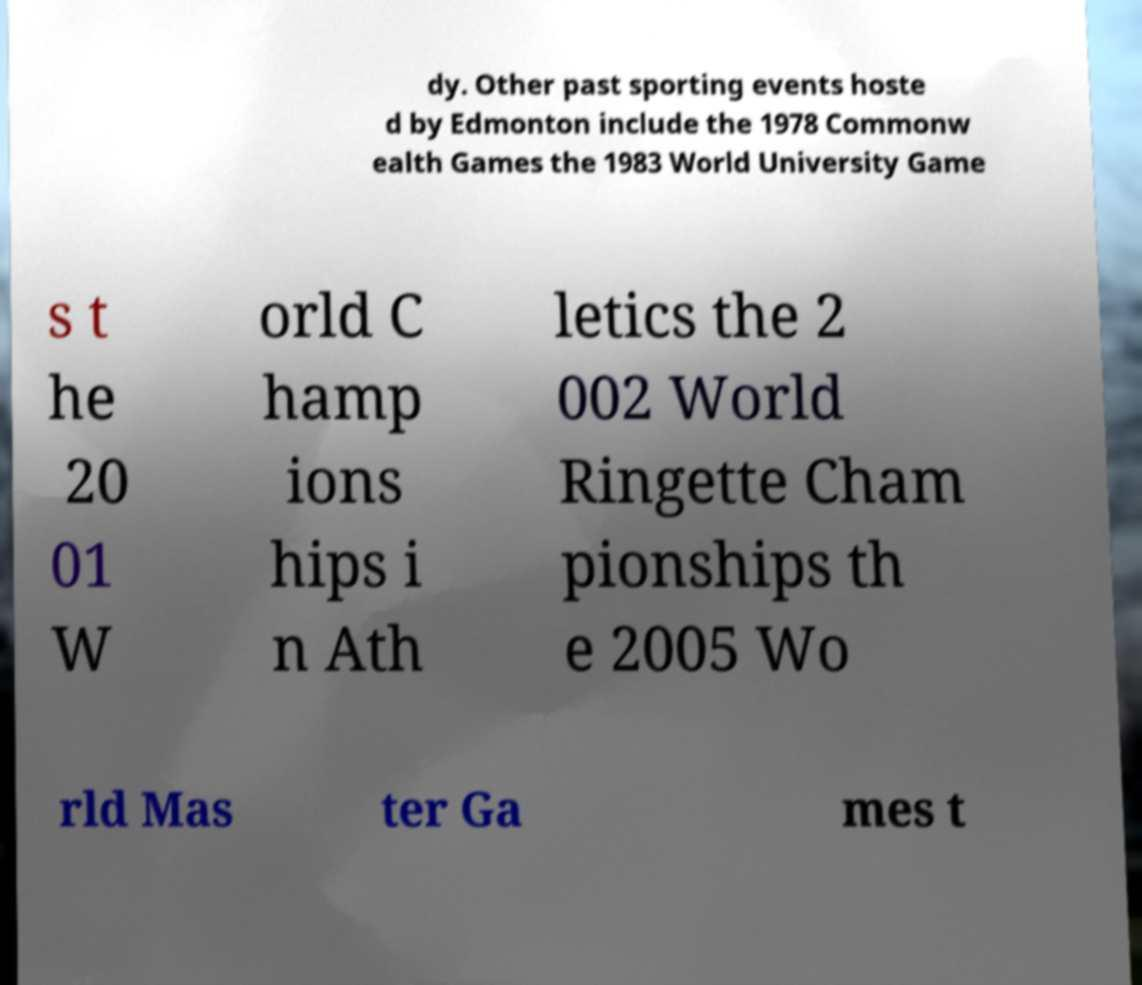Please identify and transcribe the text found in this image. dy. Other past sporting events hoste d by Edmonton include the 1978 Commonw ealth Games the 1983 World University Game s t he 20 01 W orld C hamp ions hips i n Ath letics the 2 002 World Ringette Cham pionships th e 2005 Wo rld Mas ter Ga mes t 